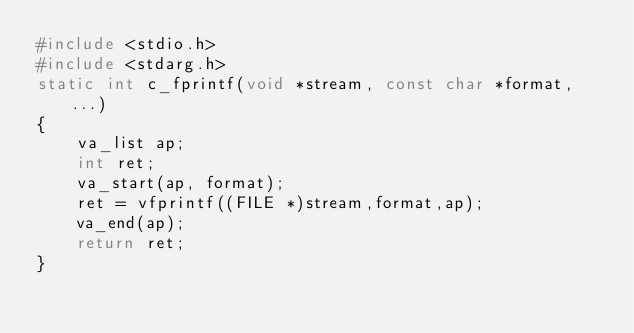<code> <loc_0><loc_0><loc_500><loc_500><_C_>#include <stdio.h>
#include <stdarg.h>
static int c_fprintf(void *stream, const char *format, ...)
{
    va_list ap;
    int ret;
    va_start(ap, format);
    ret = vfprintf((FILE *)stream,format,ap);
    va_end(ap);
    return ret;
}
</code> 